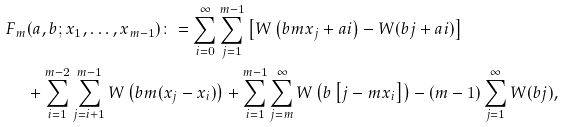<formula> <loc_0><loc_0><loc_500><loc_500>F _ { m } & ( a , b ; x _ { 1 } , \dots , x _ { m - 1 } ) \colon = \sum _ { i = 0 } ^ { \infty } \sum _ { j = 1 } ^ { m - 1 } \left [ W \left ( b m x _ { j } + a i \right ) - W ( b j + a i ) \right ] \\ & + \sum _ { i = 1 } ^ { m - 2 } \sum _ { j = i + 1 } ^ { m - 1 } W \left ( b m ( x _ { j } - x _ { i } ) \right ) + \sum _ { i = 1 } ^ { m - 1 } \sum _ { j = m } ^ { \infty } W \left ( b \left [ j - m x _ { i } \right ] \right ) - ( m - 1 ) \sum _ { j = 1 } ^ { \infty } W ( b j ) ,</formula> 